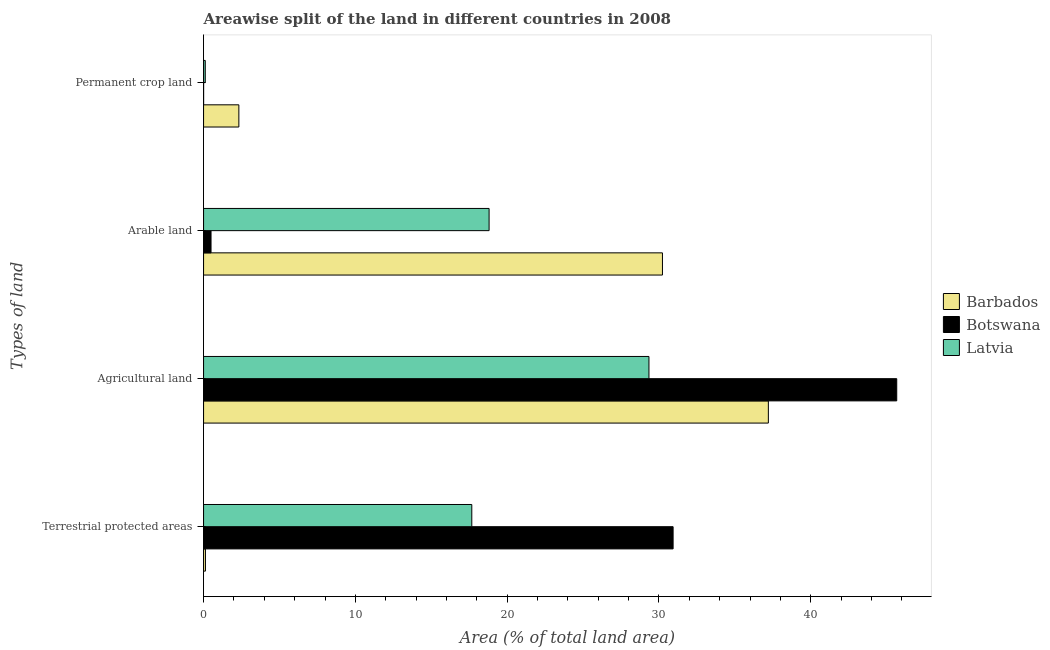How many different coloured bars are there?
Ensure brevity in your answer.  3. Are the number of bars on each tick of the Y-axis equal?
Give a very brief answer. Yes. What is the label of the 4th group of bars from the top?
Your response must be concise. Terrestrial protected areas. What is the percentage of area under agricultural land in Barbados?
Offer a terse response. 37.21. Across all countries, what is the maximum percentage of area under arable land?
Keep it short and to the point. 30.23. Across all countries, what is the minimum percentage of area under agricultural land?
Make the answer very short. 29.34. In which country was the percentage of area under arable land maximum?
Keep it short and to the point. Barbados. In which country was the percentage of area under permanent crop land minimum?
Your response must be concise. Botswana. What is the total percentage of land under terrestrial protection in the graph?
Offer a terse response. 48.73. What is the difference between the percentage of area under arable land in Barbados and that in Latvia?
Provide a succinct answer. 11.42. What is the difference between the percentage of area under permanent crop land in Botswana and the percentage of area under arable land in Barbados?
Provide a succinct answer. -30.23. What is the average percentage of area under arable land per country?
Your response must be concise. 16.51. What is the difference between the percentage of land under terrestrial protection and percentage of area under arable land in Botswana?
Provide a short and direct response. 30.44. What is the ratio of the percentage of land under terrestrial protection in Botswana to that in Barbados?
Your response must be concise. 249.2. What is the difference between the highest and the second highest percentage of area under agricultural land?
Your response must be concise. 8.46. What is the difference between the highest and the lowest percentage of land under terrestrial protection?
Offer a very short reply. 30.81. In how many countries, is the percentage of area under arable land greater than the average percentage of area under arable land taken over all countries?
Offer a very short reply. 2. What does the 2nd bar from the top in Permanent crop land represents?
Your answer should be very brief. Botswana. What does the 3rd bar from the bottom in Agricultural land represents?
Your response must be concise. Latvia. How many countries are there in the graph?
Your response must be concise. 3. Where does the legend appear in the graph?
Keep it short and to the point. Center right. What is the title of the graph?
Offer a very short reply. Areawise split of the land in different countries in 2008. What is the label or title of the X-axis?
Keep it short and to the point. Area (% of total land area). What is the label or title of the Y-axis?
Your answer should be compact. Types of land. What is the Area (% of total land area) of Barbados in Terrestrial protected areas?
Your response must be concise. 0.12. What is the Area (% of total land area) in Botswana in Terrestrial protected areas?
Offer a very short reply. 30.93. What is the Area (% of total land area) in Latvia in Terrestrial protected areas?
Make the answer very short. 17.67. What is the Area (% of total land area) of Barbados in Agricultural land?
Your answer should be compact. 37.21. What is the Area (% of total land area) of Botswana in Agricultural land?
Your answer should be compact. 45.67. What is the Area (% of total land area) in Latvia in Agricultural land?
Give a very brief answer. 29.34. What is the Area (% of total land area) of Barbados in Arable land?
Provide a succinct answer. 30.23. What is the Area (% of total land area) in Botswana in Arable land?
Offer a very short reply. 0.49. What is the Area (% of total land area) in Latvia in Arable land?
Keep it short and to the point. 18.81. What is the Area (% of total land area) of Barbados in Permanent crop land?
Provide a short and direct response. 2.33. What is the Area (% of total land area) of Botswana in Permanent crop land?
Keep it short and to the point. 0. What is the Area (% of total land area) of Latvia in Permanent crop land?
Provide a short and direct response. 0.11. Across all Types of land, what is the maximum Area (% of total land area) of Barbados?
Offer a very short reply. 37.21. Across all Types of land, what is the maximum Area (% of total land area) of Botswana?
Make the answer very short. 45.67. Across all Types of land, what is the maximum Area (% of total land area) of Latvia?
Your answer should be compact. 29.34. Across all Types of land, what is the minimum Area (% of total land area) in Barbados?
Make the answer very short. 0.12. Across all Types of land, what is the minimum Area (% of total land area) in Botswana?
Offer a very short reply. 0. Across all Types of land, what is the minimum Area (% of total land area) in Latvia?
Give a very brief answer. 0.11. What is the total Area (% of total land area) in Barbados in the graph?
Provide a short and direct response. 69.89. What is the total Area (% of total land area) of Botswana in the graph?
Your response must be concise. 77.1. What is the total Area (% of total land area) in Latvia in the graph?
Give a very brief answer. 65.94. What is the difference between the Area (% of total land area) in Barbados in Terrestrial protected areas and that in Agricultural land?
Provide a short and direct response. -37.09. What is the difference between the Area (% of total land area) in Botswana in Terrestrial protected areas and that in Agricultural land?
Offer a terse response. -14.73. What is the difference between the Area (% of total land area) of Latvia in Terrestrial protected areas and that in Agricultural land?
Your answer should be compact. -11.67. What is the difference between the Area (% of total land area) of Barbados in Terrestrial protected areas and that in Arable land?
Offer a terse response. -30.11. What is the difference between the Area (% of total land area) of Botswana in Terrestrial protected areas and that in Arable land?
Your response must be concise. 30.44. What is the difference between the Area (% of total land area) of Latvia in Terrestrial protected areas and that in Arable land?
Your answer should be very brief. -1.14. What is the difference between the Area (% of total land area) of Barbados in Terrestrial protected areas and that in Permanent crop land?
Your answer should be very brief. -2.2. What is the difference between the Area (% of total land area) of Botswana in Terrestrial protected areas and that in Permanent crop land?
Your answer should be very brief. 30.93. What is the difference between the Area (% of total land area) of Latvia in Terrestrial protected areas and that in Permanent crop land?
Give a very brief answer. 17.56. What is the difference between the Area (% of total land area) of Barbados in Agricultural land and that in Arable land?
Your answer should be very brief. 6.98. What is the difference between the Area (% of total land area) of Botswana in Agricultural land and that in Arable land?
Your response must be concise. 45.17. What is the difference between the Area (% of total land area) of Latvia in Agricultural land and that in Arable land?
Your answer should be very brief. 10.53. What is the difference between the Area (% of total land area) of Barbados in Agricultural land and that in Permanent crop land?
Your response must be concise. 34.88. What is the difference between the Area (% of total land area) in Botswana in Agricultural land and that in Permanent crop land?
Provide a short and direct response. 45.66. What is the difference between the Area (% of total land area) of Latvia in Agricultural land and that in Permanent crop land?
Make the answer very short. 29.23. What is the difference between the Area (% of total land area) of Barbados in Arable land and that in Permanent crop land?
Offer a very short reply. 27.91. What is the difference between the Area (% of total land area) in Botswana in Arable land and that in Permanent crop land?
Offer a very short reply. 0.49. What is the difference between the Area (% of total land area) in Latvia in Arable land and that in Permanent crop land?
Offer a very short reply. 18.7. What is the difference between the Area (% of total land area) of Barbados in Terrestrial protected areas and the Area (% of total land area) of Botswana in Agricultural land?
Your response must be concise. -45.54. What is the difference between the Area (% of total land area) of Barbados in Terrestrial protected areas and the Area (% of total land area) of Latvia in Agricultural land?
Provide a succinct answer. -29.22. What is the difference between the Area (% of total land area) of Botswana in Terrestrial protected areas and the Area (% of total land area) of Latvia in Agricultural land?
Keep it short and to the point. 1.59. What is the difference between the Area (% of total land area) in Barbados in Terrestrial protected areas and the Area (% of total land area) in Botswana in Arable land?
Offer a very short reply. -0.37. What is the difference between the Area (% of total land area) of Barbados in Terrestrial protected areas and the Area (% of total land area) of Latvia in Arable land?
Your answer should be compact. -18.69. What is the difference between the Area (% of total land area) in Botswana in Terrestrial protected areas and the Area (% of total land area) in Latvia in Arable land?
Your response must be concise. 12.12. What is the difference between the Area (% of total land area) in Barbados in Terrestrial protected areas and the Area (% of total land area) in Botswana in Permanent crop land?
Offer a very short reply. 0.12. What is the difference between the Area (% of total land area) of Barbados in Terrestrial protected areas and the Area (% of total land area) of Latvia in Permanent crop land?
Offer a terse response. 0.01. What is the difference between the Area (% of total land area) of Botswana in Terrestrial protected areas and the Area (% of total land area) of Latvia in Permanent crop land?
Your response must be concise. 30.82. What is the difference between the Area (% of total land area) of Barbados in Agricultural land and the Area (% of total land area) of Botswana in Arable land?
Ensure brevity in your answer.  36.72. What is the difference between the Area (% of total land area) of Barbados in Agricultural land and the Area (% of total land area) of Latvia in Arable land?
Offer a very short reply. 18.4. What is the difference between the Area (% of total land area) of Botswana in Agricultural land and the Area (% of total land area) of Latvia in Arable land?
Keep it short and to the point. 26.86. What is the difference between the Area (% of total land area) in Barbados in Agricultural land and the Area (% of total land area) in Botswana in Permanent crop land?
Make the answer very short. 37.21. What is the difference between the Area (% of total land area) in Barbados in Agricultural land and the Area (% of total land area) in Latvia in Permanent crop land?
Your answer should be compact. 37.1. What is the difference between the Area (% of total land area) of Botswana in Agricultural land and the Area (% of total land area) of Latvia in Permanent crop land?
Your answer should be compact. 45.55. What is the difference between the Area (% of total land area) in Barbados in Arable land and the Area (% of total land area) in Botswana in Permanent crop land?
Provide a short and direct response. 30.23. What is the difference between the Area (% of total land area) of Barbados in Arable land and the Area (% of total land area) of Latvia in Permanent crop land?
Give a very brief answer. 30.12. What is the difference between the Area (% of total land area) of Botswana in Arable land and the Area (% of total land area) of Latvia in Permanent crop land?
Keep it short and to the point. 0.38. What is the average Area (% of total land area) of Barbados per Types of land?
Ensure brevity in your answer.  17.47. What is the average Area (% of total land area) of Botswana per Types of land?
Make the answer very short. 19.27. What is the average Area (% of total land area) of Latvia per Types of land?
Give a very brief answer. 16.48. What is the difference between the Area (% of total land area) of Barbados and Area (% of total land area) of Botswana in Terrestrial protected areas?
Offer a very short reply. -30.81. What is the difference between the Area (% of total land area) of Barbados and Area (% of total land area) of Latvia in Terrestrial protected areas?
Offer a terse response. -17.55. What is the difference between the Area (% of total land area) in Botswana and Area (% of total land area) in Latvia in Terrestrial protected areas?
Keep it short and to the point. 13.26. What is the difference between the Area (% of total land area) of Barbados and Area (% of total land area) of Botswana in Agricultural land?
Keep it short and to the point. -8.46. What is the difference between the Area (% of total land area) of Barbados and Area (% of total land area) of Latvia in Agricultural land?
Your answer should be compact. 7.87. What is the difference between the Area (% of total land area) in Botswana and Area (% of total land area) in Latvia in Agricultural land?
Ensure brevity in your answer.  16.32. What is the difference between the Area (% of total land area) of Barbados and Area (% of total land area) of Botswana in Arable land?
Your answer should be very brief. 29.74. What is the difference between the Area (% of total land area) in Barbados and Area (% of total land area) in Latvia in Arable land?
Ensure brevity in your answer.  11.42. What is the difference between the Area (% of total land area) in Botswana and Area (% of total land area) in Latvia in Arable land?
Give a very brief answer. -18.32. What is the difference between the Area (% of total land area) in Barbados and Area (% of total land area) in Botswana in Permanent crop land?
Offer a terse response. 2.32. What is the difference between the Area (% of total land area) in Barbados and Area (% of total land area) in Latvia in Permanent crop land?
Give a very brief answer. 2.21. What is the difference between the Area (% of total land area) in Botswana and Area (% of total land area) in Latvia in Permanent crop land?
Ensure brevity in your answer.  -0.11. What is the ratio of the Area (% of total land area) in Barbados in Terrestrial protected areas to that in Agricultural land?
Keep it short and to the point. 0. What is the ratio of the Area (% of total land area) in Botswana in Terrestrial protected areas to that in Agricultural land?
Provide a short and direct response. 0.68. What is the ratio of the Area (% of total land area) of Latvia in Terrestrial protected areas to that in Agricultural land?
Offer a very short reply. 0.6. What is the ratio of the Area (% of total land area) in Barbados in Terrestrial protected areas to that in Arable land?
Offer a terse response. 0. What is the ratio of the Area (% of total land area) of Botswana in Terrestrial protected areas to that in Arable land?
Keep it short and to the point. 62.84. What is the ratio of the Area (% of total land area) of Latvia in Terrestrial protected areas to that in Arable land?
Your answer should be very brief. 0.94. What is the ratio of the Area (% of total land area) in Barbados in Terrestrial protected areas to that in Permanent crop land?
Keep it short and to the point. 0.05. What is the ratio of the Area (% of total land area) in Botswana in Terrestrial protected areas to that in Permanent crop land?
Your response must be concise. 8765.54. What is the ratio of the Area (% of total land area) of Latvia in Terrestrial protected areas to that in Permanent crop land?
Make the answer very short. 157.01. What is the ratio of the Area (% of total land area) of Barbados in Agricultural land to that in Arable land?
Your answer should be compact. 1.23. What is the ratio of the Area (% of total land area) of Botswana in Agricultural land to that in Arable land?
Your answer should be compact. 92.76. What is the ratio of the Area (% of total land area) of Latvia in Agricultural land to that in Arable land?
Your answer should be compact. 1.56. What is the ratio of the Area (% of total land area) in Botswana in Agricultural land to that in Permanent crop land?
Give a very brief answer. 1.29e+04. What is the ratio of the Area (% of total land area) in Latvia in Agricultural land to that in Permanent crop land?
Offer a terse response. 260.71. What is the ratio of the Area (% of total land area) in Botswana in Arable land to that in Permanent crop land?
Make the answer very short. 139.5. What is the ratio of the Area (% of total land area) of Latvia in Arable land to that in Permanent crop land?
Make the answer very short. 167.14. What is the difference between the highest and the second highest Area (% of total land area) in Barbados?
Provide a succinct answer. 6.98. What is the difference between the highest and the second highest Area (% of total land area) of Botswana?
Keep it short and to the point. 14.73. What is the difference between the highest and the second highest Area (% of total land area) of Latvia?
Ensure brevity in your answer.  10.53. What is the difference between the highest and the lowest Area (% of total land area) in Barbados?
Make the answer very short. 37.09. What is the difference between the highest and the lowest Area (% of total land area) in Botswana?
Provide a succinct answer. 45.66. What is the difference between the highest and the lowest Area (% of total land area) in Latvia?
Provide a short and direct response. 29.23. 